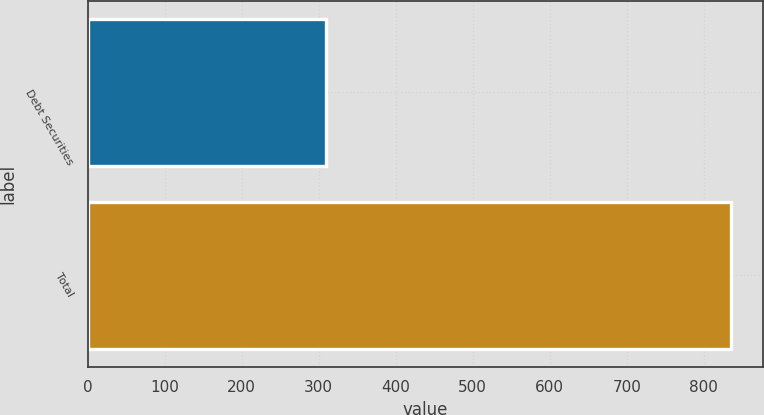<chart> <loc_0><loc_0><loc_500><loc_500><bar_chart><fcel>Debt Securities<fcel>Total<nl><fcel>309.3<fcel>834.7<nl></chart> 